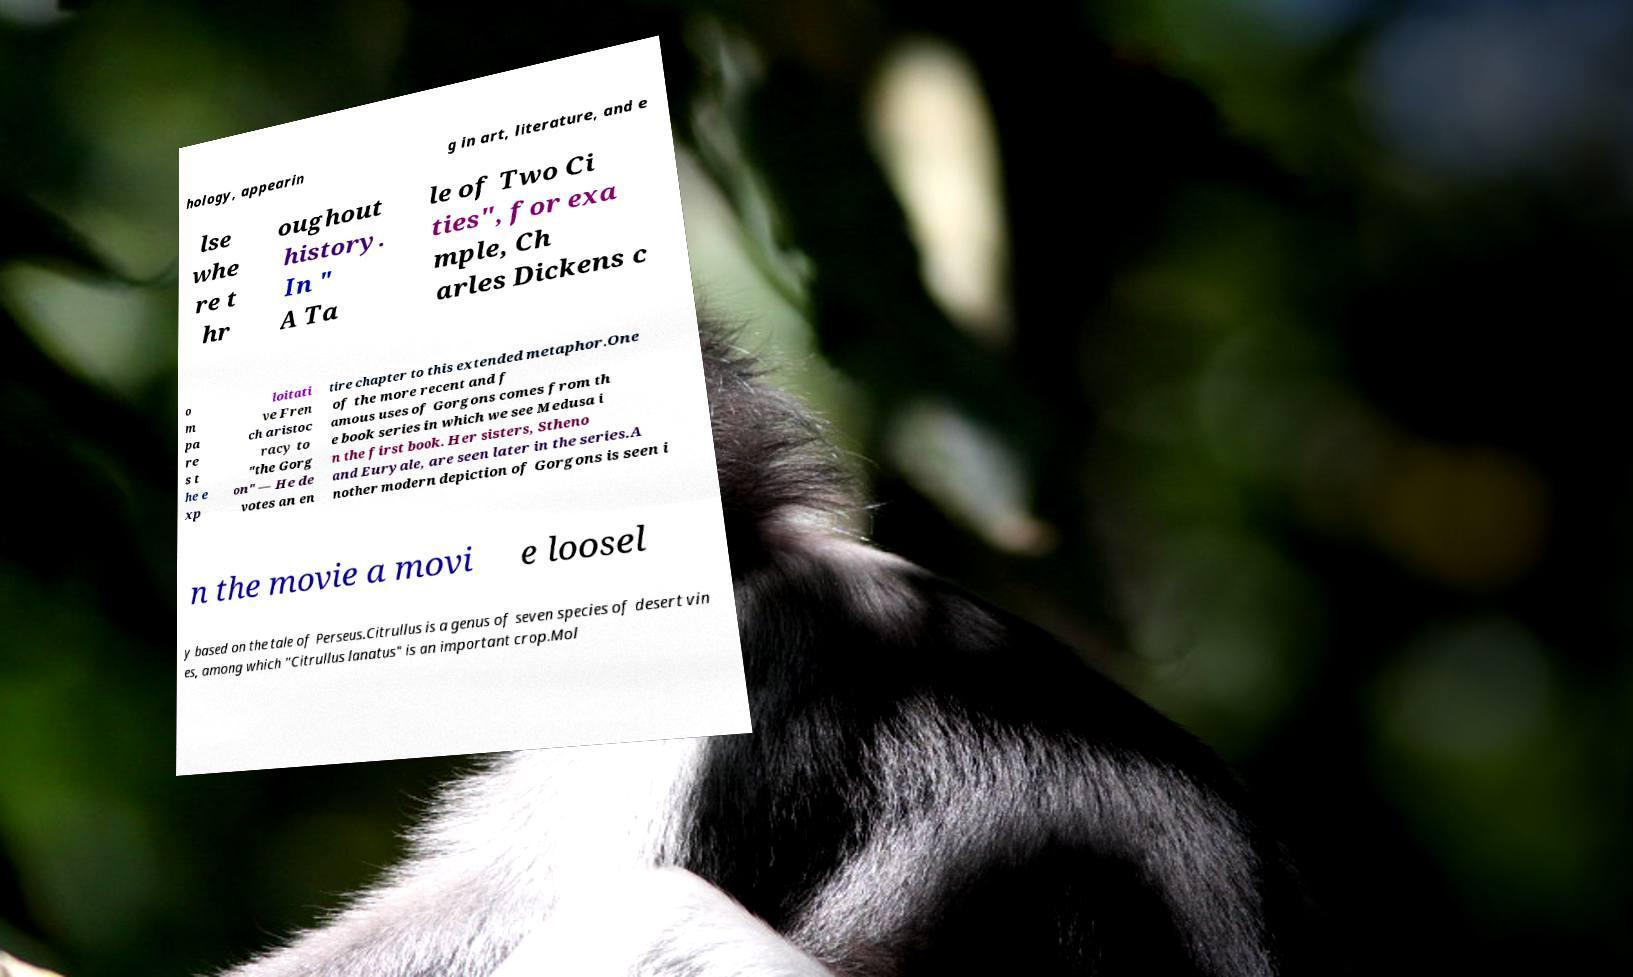Please identify and transcribe the text found in this image. hology, appearin g in art, literature, and e lse whe re t hr oughout history. In " A Ta le of Two Ci ties", for exa mple, Ch arles Dickens c o m pa re s t he e xp loitati ve Fren ch aristoc racy to "the Gorg on" — He de votes an en tire chapter to this extended metaphor.One of the more recent and f amous uses of Gorgons comes from th e book series in which we see Medusa i n the first book. Her sisters, Stheno and Euryale, are seen later in the series.A nother modern depiction of Gorgons is seen i n the movie a movi e loosel y based on the tale of Perseus.Citrullus is a genus of seven species of desert vin es, among which "Citrullus lanatus" is an important crop.Mol 